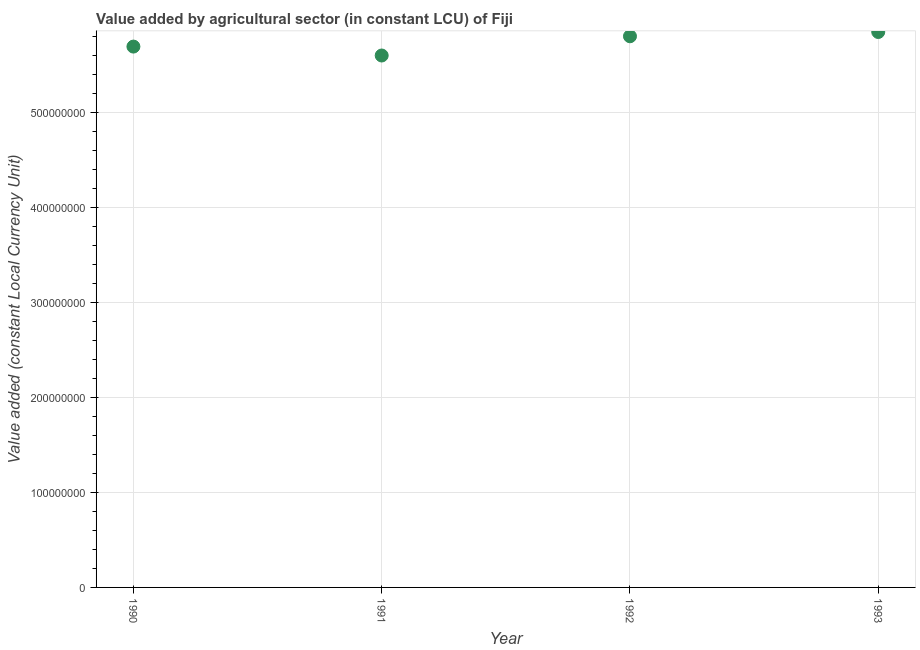What is the value added by agriculture sector in 1993?
Your response must be concise. 5.85e+08. Across all years, what is the maximum value added by agriculture sector?
Your response must be concise. 5.85e+08. Across all years, what is the minimum value added by agriculture sector?
Offer a terse response. 5.60e+08. What is the sum of the value added by agriculture sector?
Keep it short and to the point. 2.29e+09. What is the difference between the value added by agriculture sector in 1991 and 1992?
Make the answer very short. -2.02e+07. What is the average value added by agriculture sector per year?
Give a very brief answer. 5.73e+08. What is the median value added by agriculture sector?
Your answer should be compact. 5.75e+08. What is the ratio of the value added by agriculture sector in 1990 to that in 1993?
Your answer should be compact. 0.97. Is the value added by agriculture sector in 1990 less than that in 1993?
Your response must be concise. Yes. What is the difference between the highest and the second highest value added by agriculture sector?
Give a very brief answer. 4.50e+06. What is the difference between the highest and the lowest value added by agriculture sector?
Keep it short and to the point. 2.47e+07. How many dotlines are there?
Your answer should be very brief. 1. Are the values on the major ticks of Y-axis written in scientific E-notation?
Ensure brevity in your answer.  No. Does the graph contain any zero values?
Ensure brevity in your answer.  No. Does the graph contain grids?
Offer a terse response. Yes. What is the title of the graph?
Your response must be concise. Value added by agricultural sector (in constant LCU) of Fiji. What is the label or title of the Y-axis?
Keep it short and to the point. Value added (constant Local Currency Unit). What is the Value added (constant Local Currency Unit) in 1990?
Your answer should be compact. 5.69e+08. What is the Value added (constant Local Currency Unit) in 1991?
Ensure brevity in your answer.  5.60e+08. What is the Value added (constant Local Currency Unit) in 1992?
Your answer should be very brief. 5.80e+08. What is the Value added (constant Local Currency Unit) in 1993?
Make the answer very short. 5.85e+08. What is the difference between the Value added (constant Local Currency Unit) in 1990 and 1991?
Your answer should be compact. 9.39e+06. What is the difference between the Value added (constant Local Currency Unit) in 1990 and 1992?
Offer a terse response. -1.09e+07. What is the difference between the Value added (constant Local Currency Unit) in 1990 and 1993?
Offer a very short reply. -1.54e+07. What is the difference between the Value added (constant Local Currency Unit) in 1991 and 1992?
Make the answer very short. -2.02e+07. What is the difference between the Value added (constant Local Currency Unit) in 1991 and 1993?
Provide a short and direct response. -2.47e+07. What is the difference between the Value added (constant Local Currency Unit) in 1992 and 1993?
Your answer should be compact. -4.50e+06. What is the ratio of the Value added (constant Local Currency Unit) in 1990 to that in 1991?
Offer a terse response. 1.02. What is the ratio of the Value added (constant Local Currency Unit) in 1990 to that in 1993?
Your response must be concise. 0.97. What is the ratio of the Value added (constant Local Currency Unit) in 1991 to that in 1992?
Give a very brief answer. 0.96. What is the ratio of the Value added (constant Local Currency Unit) in 1991 to that in 1993?
Ensure brevity in your answer.  0.96. What is the ratio of the Value added (constant Local Currency Unit) in 1992 to that in 1993?
Offer a very short reply. 0.99. 